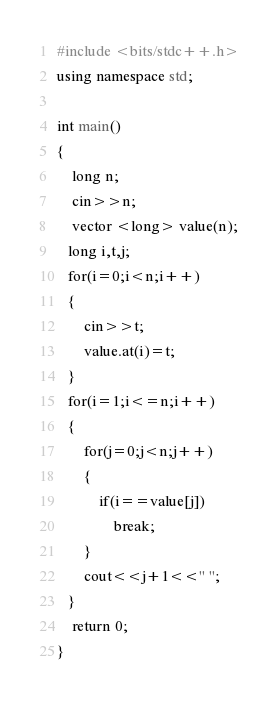<code> <loc_0><loc_0><loc_500><loc_500><_C++_>#include <bits/stdc++.h>
using namespace std;

int main()
{
    long n;
    cin>>n;
    vector <long> value(n);
   long i,t,j;
   for(i=0;i<n;i++)
   {
       cin>>t;
       value.at(i)=t;
   }
   for(i=1;i<=n;i++)
   {
       for(j=0;j<n;j++)
       {
           if(i==value[j])
               break;
       }
       cout<<j+1<<" ";
   }
    return 0;
}
</code> 